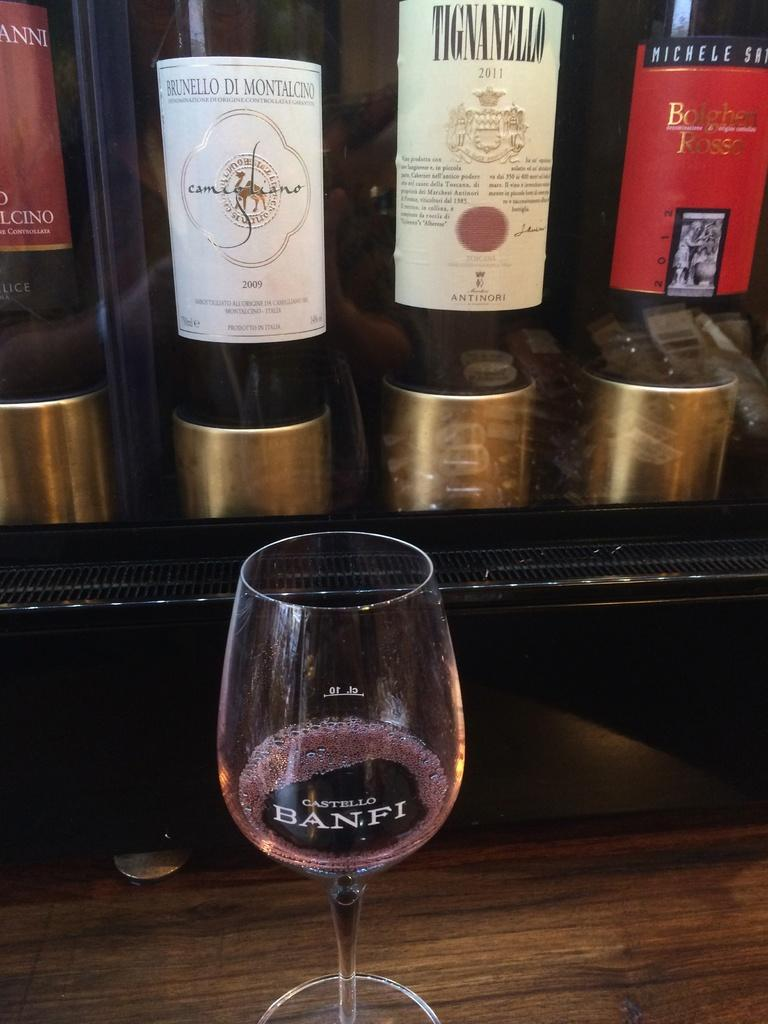What is the main object in the image? There is a table in the image. What is placed on the table? There is a wine glass on the table. What can be seen in the background of the image? There are hoardings visible in the background of the image. What grade of wood is the table made of in the image? The facts provided do not mention the grade or type of wood the table is made of, so it cannot be determined from the image. 